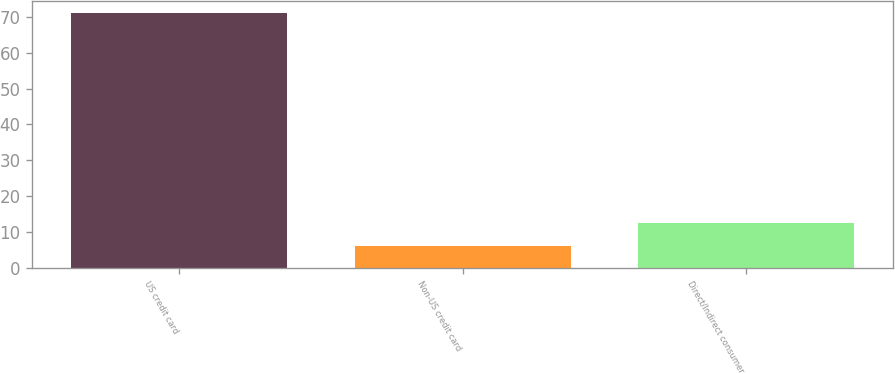Convert chart. <chart><loc_0><loc_0><loc_500><loc_500><bar_chart><fcel>US credit card<fcel>Non-US credit card<fcel>Direct/Indirect consumer<nl><fcel>71<fcel>6<fcel>12.5<nl></chart> 